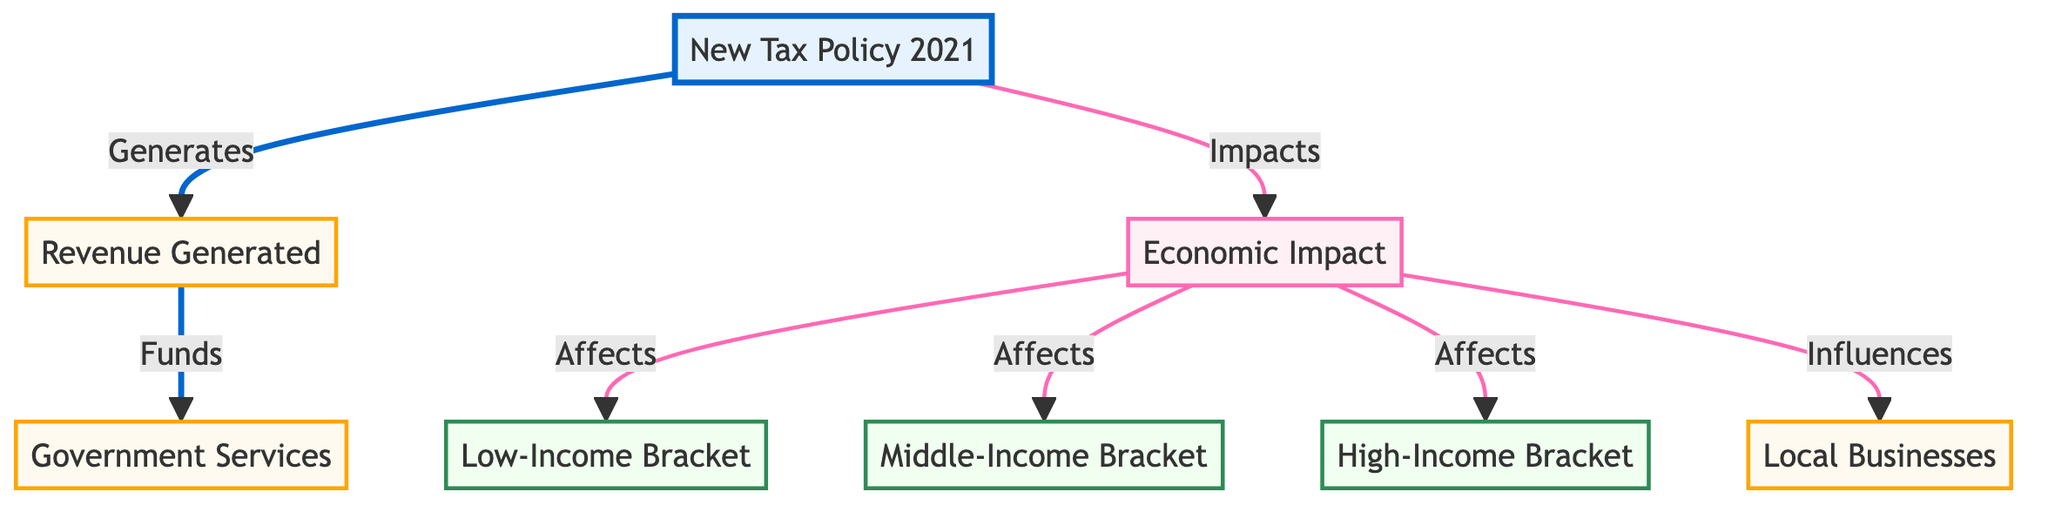What is the primary output of the new tax policy? The primary output of the new tax policy is the revenue generated. From the diagram, the arrow from the "New Tax Policy 2021" leads directly to the "Revenue Generated" node, indicating this relationship.
Answer: Revenue Generated How many income brackets are affected by the economic impact? The diagram shows three income brackets: Low-Income, Middle-Income, and High-Income. Each of these brackets is connected to the "Economic Impact" node, indicating they are all affected.
Answer: Three What do government services receive funding from? According to the diagram, government services receive funding from the revenue generated by the new tax policy. The connection from "Revenue Generated" to "Government Services" shows this funding flow.
Answer: Revenue Generated Which segment does the 'Economic Impact' influence? The 'Economic Impact' influences low-income, medium-income, high-income segments, and local businesses. This is clear as the diagram shows lines linking "Economic Impact" to these segments directly.
Answer: Low-Income, Medium-Income, High-Income, Local Businesses How does the new tax policy impact the economy? The new tax policy impacts the economy by influencing the economic impact node, which further affects various income brackets and local businesses. The connections lead us to understand the broader economic implications stemming from this policy.
Answer: By influencing income brackets and local businesses What kind of diagram is presented in the flowchart? The presented diagram is a Textbook Diagram, which typically visually represents relationships between policies, effects, and impacts. The use of different classes and colors for nodes indicates categorization and flow, common in educational contexts.
Answer: Textbook Diagram 